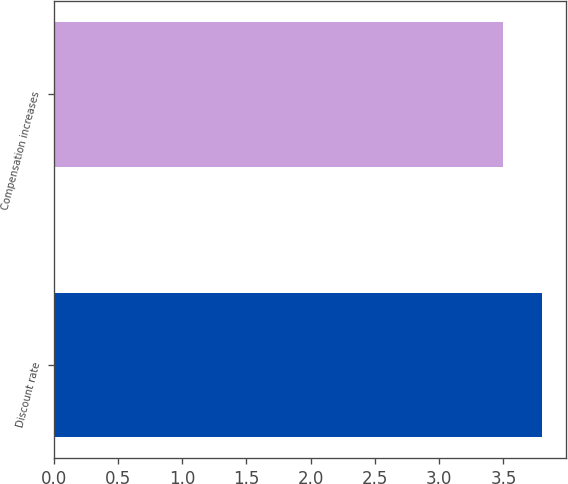Convert chart. <chart><loc_0><loc_0><loc_500><loc_500><bar_chart><fcel>Discount rate<fcel>Compensation increases<nl><fcel>3.8<fcel>3.5<nl></chart> 